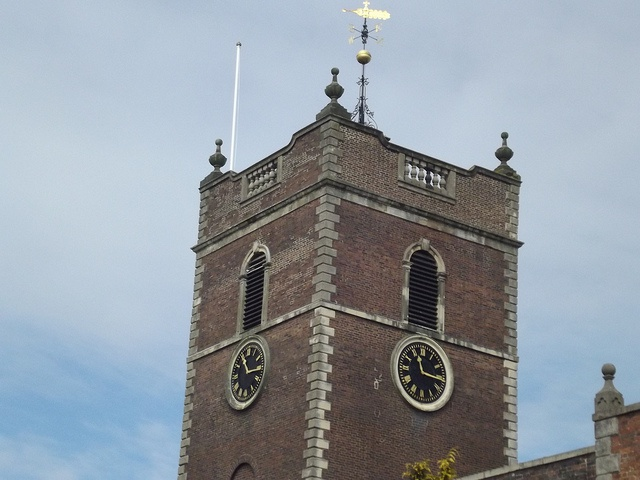Describe the objects in this image and their specific colors. I can see clock in lightblue, black, gray, darkgray, and tan tones and clock in lightblue, black, gray, and darkgray tones in this image. 